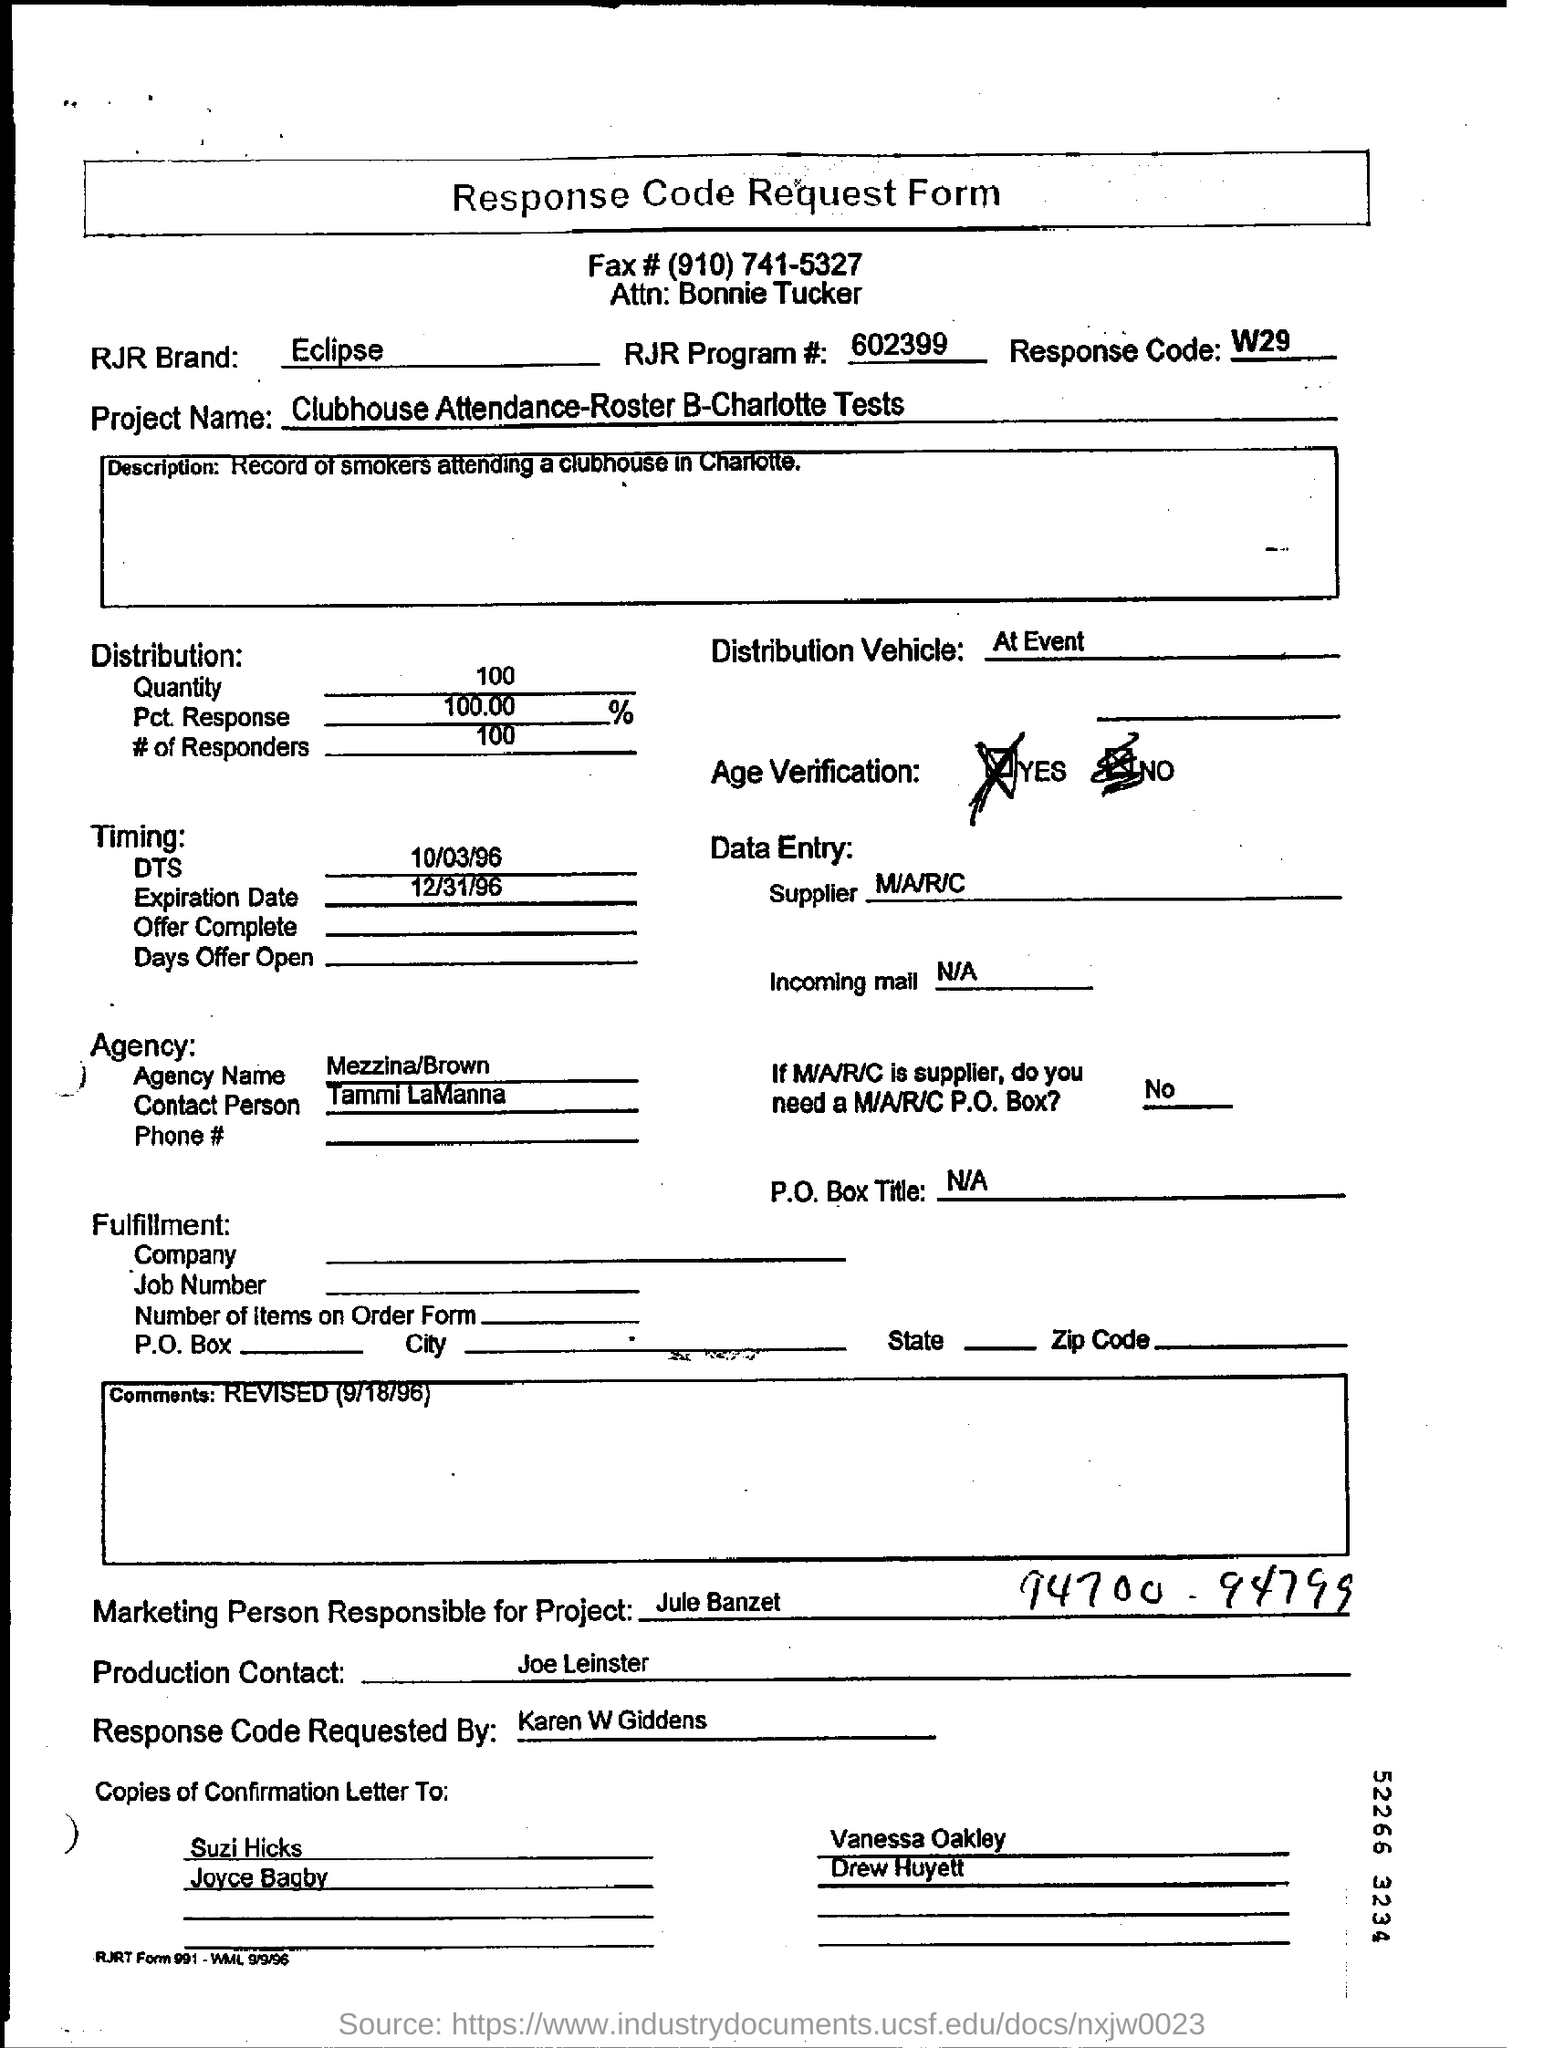What is the Title of the document?
Your answer should be very brief. Response code request form. What is the Fax#?
Make the answer very short. (910) 741-5327. Which is the RJR Brand?
Give a very brief answer. Eclipse. What is the RJR Program#?
Provide a succinct answer. 602399. What is the Response code?
Keep it short and to the point. W29. What is the distribution quantity?
Ensure brevity in your answer.  100. What is the Pct. Response?
Offer a very short reply. 100.00%. What is the distribution vehicle?
Your answer should be very brief. AT EVENT. What is the agency name?
Keep it short and to the point. Mezzina/Brown. Who is the contact person?
Provide a succinct answer. TAMMI LAMANNA. 